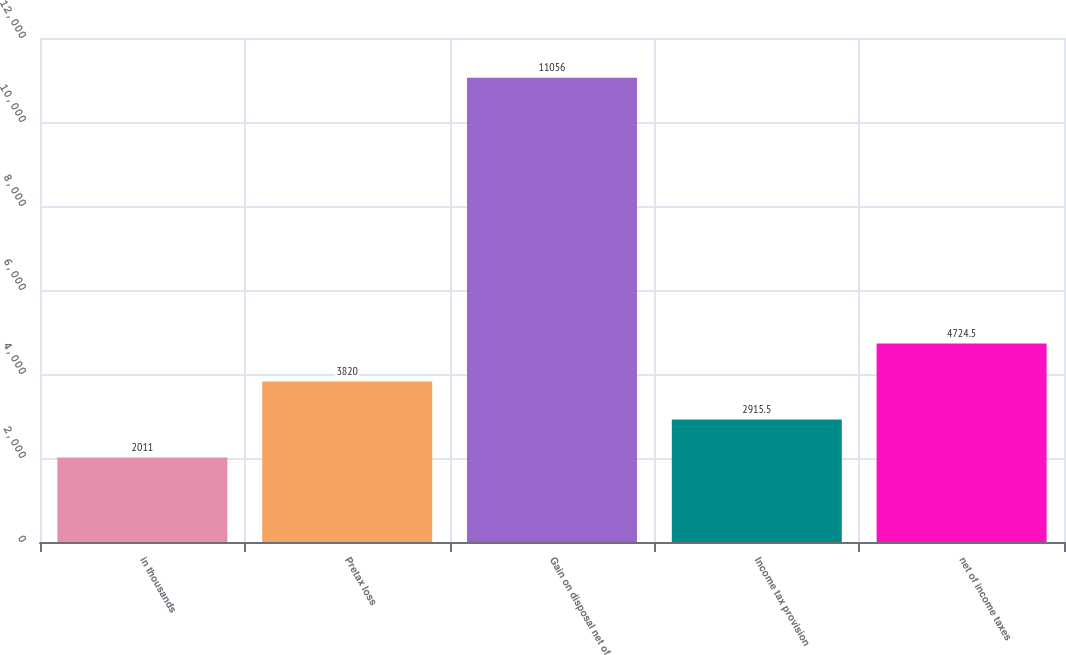Convert chart to OTSL. <chart><loc_0><loc_0><loc_500><loc_500><bar_chart><fcel>in thousands<fcel>Pretax loss<fcel>Gain on disposal net of<fcel>Income tax provision<fcel>net of income taxes<nl><fcel>2011<fcel>3820<fcel>11056<fcel>2915.5<fcel>4724.5<nl></chart> 